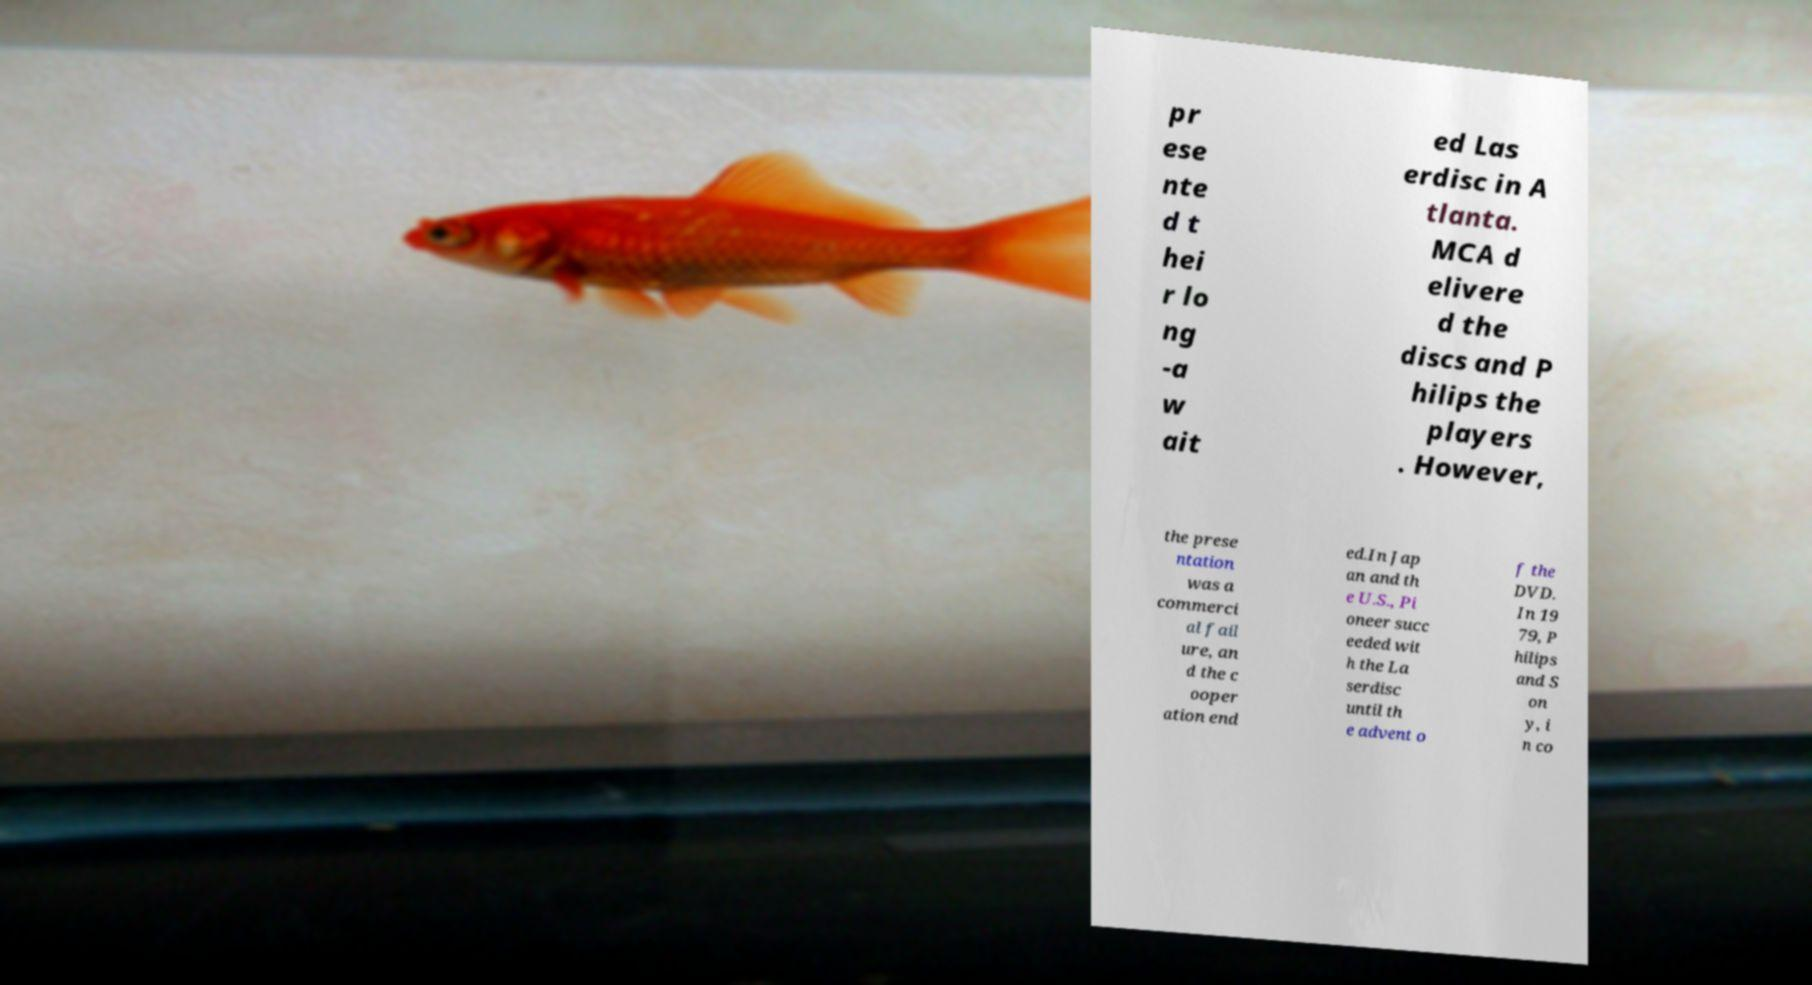Please read and relay the text visible in this image. What does it say? pr ese nte d t hei r lo ng -a w ait ed Las erdisc in A tlanta. MCA d elivere d the discs and P hilips the players . However, the prese ntation was a commerci al fail ure, an d the c ooper ation end ed.In Jap an and th e U.S., Pi oneer succ eeded wit h the La serdisc until th e advent o f the DVD. In 19 79, P hilips and S on y, i n co 